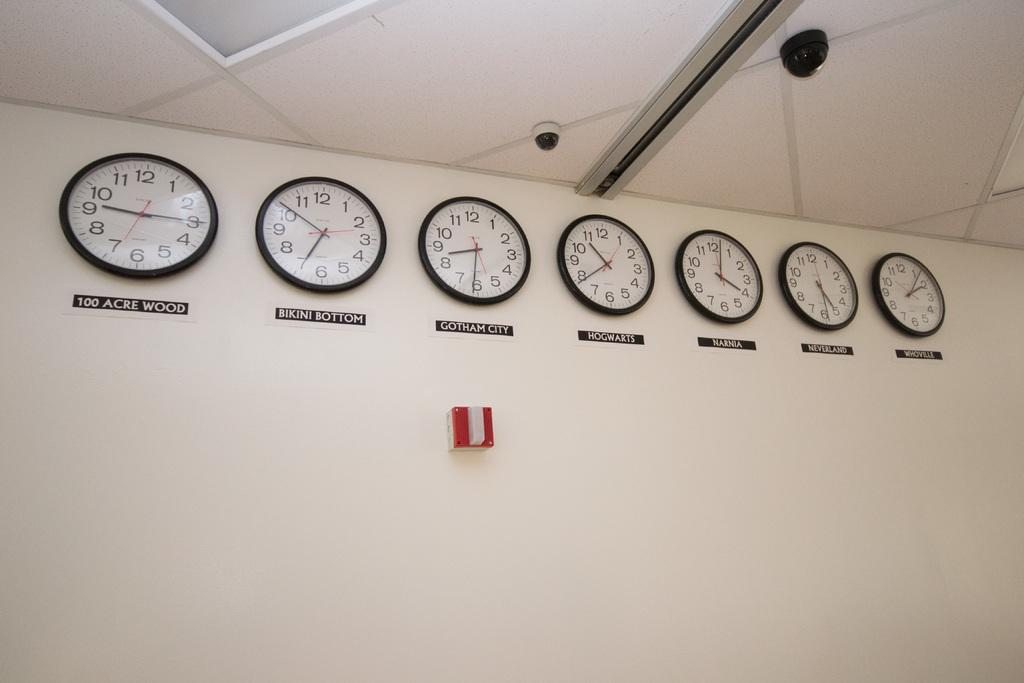<image>
Create a compact narrative representing the image presented. a line of clocks show the times in cartoon places such as bikini bottom and 100 acre woods 